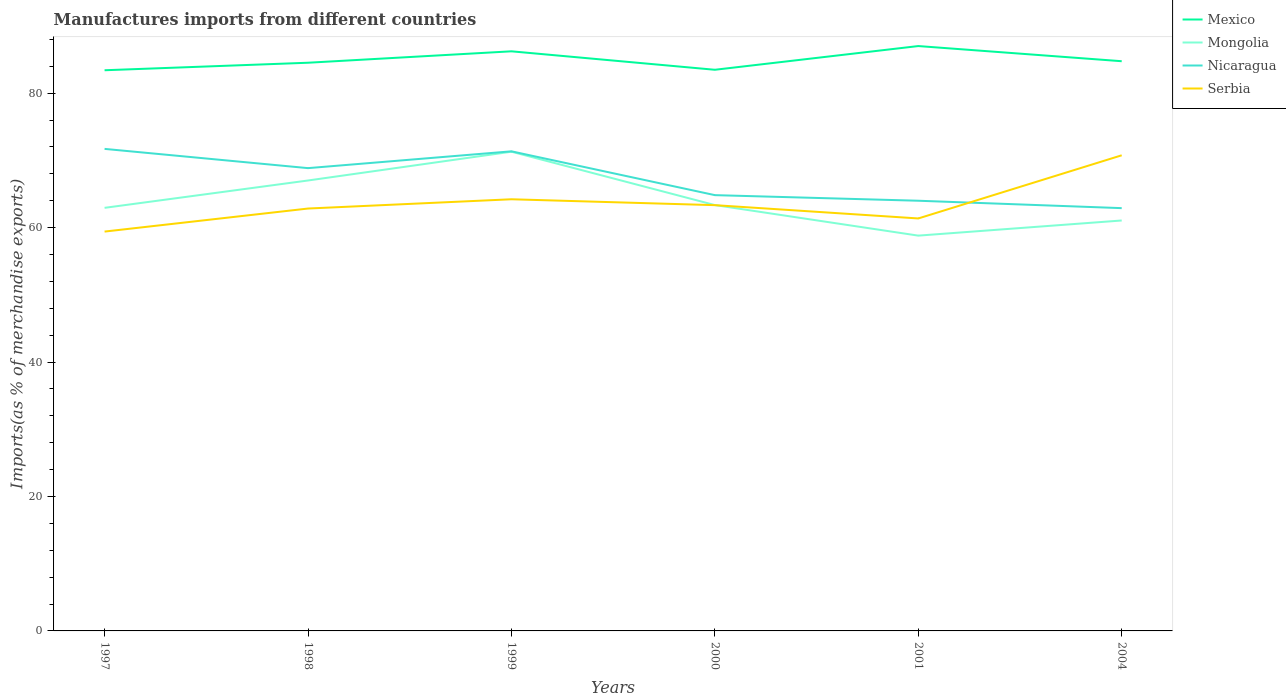Is the number of lines equal to the number of legend labels?
Your response must be concise. Yes. Across all years, what is the maximum percentage of imports to different countries in Serbia?
Give a very brief answer. 59.41. What is the total percentage of imports to different countries in Serbia in the graph?
Provide a short and direct response. -4.81. What is the difference between the highest and the second highest percentage of imports to different countries in Nicaragua?
Provide a succinct answer. 8.82. What is the difference between the highest and the lowest percentage of imports to different countries in Mongolia?
Your response must be concise. 2. Is the percentage of imports to different countries in Serbia strictly greater than the percentage of imports to different countries in Mexico over the years?
Ensure brevity in your answer.  Yes. What is the difference between two consecutive major ticks on the Y-axis?
Your answer should be very brief. 20. Does the graph contain any zero values?
Your response must be concise. No. How many legend labels are there?
Offer a very short reply. 4. How are the legend labels stacked?
Provide a short and direct response. Vertical. What is the title of the graph?
Your answer should be compact. Manufactures imports from different countries. Does "Netherlands" appear as one of the legend labels in the graph?
Ensure brevity in your answer.  No. What is the label or title of the Y-axis?
Ensure brevity in your answer.  Imports(as % of merchandise exports). What is the Imports(as % of merchandise exports) of Mexico in 1997?
Your response must be concise. 83.41. What is the Imports(as % of merchandise exports) of Mongolia in 1997?
Your response must be concise. 62.94. What is the Imports(as % of merchandise exports) in Nicaragua in 1997?
Your response must be concise. 71.71. What is the Imports(as % of merchandise exports) in Serbia in 1997?
Offer a terse response. 59.41. What is the Imports(as % of merchandise exports) of Mexico in 1998?
Your answer should be compact. 84.52. What is the Imports(as % of merchandise exports) of Mongolia in 1998?
Provide a short and direct response. 67.01. What is the Imports(as % of merchandise exports) of Nicaragua in 1998?
Make the answer very short. 68.84. What is the Imports(as % of merchandise exports) of Serbia in 1998?
Give a very brief answer. 62.83. What is the Imports(as % of merchandise exports) of Mexico in 1999?
Keep it short and to the point. 86.22. What is the Imports(as % of merchandise exports) of Mongolia in 1999?
Keep it short and to the point. 71.29. What is the Imports(as % of merchandise exports) in Nicaragua in 1999?
Provide a short and direct response. 71.34. What is the Imports(as % of merchandise exports) of Serbia in 1999?
Your answer should be very brief. 64.21. What is the Imports(as % of merchandise exports) in Mexico in 2000?
Your response must be concise. 83.48. What is the Imports(as % of merchandise exports) of Mongolia in 2000?
Provide a short and direct response. 63.35. What is the Imports(as % of merchandise exports) in Nicaragua in 2000?
Provide a short and direct response. 64.83. What is the Imports(as % of merchandise exports) of Serbia in 2000?
Make the answer very short. 63.34. What is the Imports(as % of merchandise exports) of Mexico in 2001?
Make the answer very short. 87. What is the Imports(as % of merchandise exports) of Mongolia in 2001?
Keep it short and to the point. 58.8. What is the Imports(as % of merchandise exports) in Nicaragua in 2001?
Make the answer very short. 63.99. What is the Imports(as % of merchandise exports) of Serbia in 2001?
Provide a short and direct response. 61.36. What is the Imports(as % of merchandise exports) of Mexico in 2004?
Give a very brief answer. 84.75. What is the Imports(as % of merchandise exports) of Mongolia in 2004?
Your response must be concise. 61.06. What is the Imports(as % of merchandise exports) of Nicaragua in 2004?
Provide a succinct answer. 62.89. What is the Imports(as % of merchandise exports) in Serbia in 2004?
Provide a short and direct response. 70.75. Across all years, what is the maximum Imports(as % of merchandise exports) of Mexico?
Provide a succinct answer. 87. Across all years, what is the maximum Imports(as % of merchandise exports) of Mongolia?
Your answer should be very brief. 71.29. Across all years, what is the maximum Imports(as % of merchandise exports) of Nicaragua?
Your answer should be compact. 71.71. Across all years, what is the maximum Imports(as % of merchandise exports) of Serbia?
Your response must be concise. 70.75. Across all years, what is the minimum Imports(as % of merchandise exports) in Mexico?
Give a very brief answer. 83.41. Across all years, what is the minimum Imports(as % of merchandise exports) in Mongolia?
Ensure brevity in your answer.  58.8. Across all years, what is the minimum Imports(as % of merchandise exports) of Nicaragua?
Ensure brevity in your answer.  62.89. Across all years, what is the minimum Imports(as % of merchandise exports) in Serbia?
Your answer should be very brief. 59.41. What is the total Imports(as % of merchandise exports) in Mexico in the graph?
Offer a very short reply. 509.38. What is the total Imports(as % of merchandise exports) in Mongolia in the graph?
Offer a terse response. 384.44. What is the total Imports(as % of merchandise exports) in Nicaragua in the graph?
Provide a succinct answer. 403.61. What is the total Imports(as % of merchandise exports) in Serbia in the graph?
Your response must be concise. 381.9. What is the difference between the Imports(as % of merchandise exports) of Mexico in 1997 and that in 1998?
Your answer should be compact. -1.12. What is the difference between the Imports(as % of merchandise exports) in Mongolia in 1997 and that in 1998?
Offer a terse response. -4.07. What is the difference between the Imports(as % of merchandise exports) of Nicaragua in 1997 and that in 1998?
Provide a short and direct response. 2.86. What is the difference between the Imports(as % of merchandise exports) in Serbia in 1997 and that in 1998?
Offer a very short reply. -3.43. What is the difference between the Imports(as % of merchandise exports) in Mexico in 1997 and that in 1999?
Offer a terse response. -2.82. What is the difference between the Imports(as % of merchandise exports) in Mongolia in 1997 and that in 1999?
Give a very brief answer. -8.35. What is the difference between the Imports(as % of merchandise exports) in Nicaragua in 1997 and that in 1999?
Make the answer very short. 0.36. What is the difference between the Imports(as % of merchandise exports) of Serbia in 1997 and that in 1999?
Provide a succinct answer. -4.81. What is the difference between the Imports(as % of merchandise exports) in Mexico in 1997 and that in 2000?
Your response must be concise. -0.07. What is the difference between the Imports(as % of merchandise exports) of Mongolia in 1997 and that in 2000?
Ensure brevity in your answer.  -0.41. What is the difference between the Imports(as % of merchandise exports) of Nicaragua in 1997 and that in 2000?
Provide a succinct answer. 6.88. What is the difference between the Imports(as % of merchandise exports) in Serbia in 1997 and that in 2000?
Offer a very short reply. -3.93. What is the difference between the Imports(as % of merchandise exports) of Mexico in 1997 and that in 2001?
Give a very brief answer. -3.6. What is the difference between the Imports(as % of merchandise exports) in Mongolia in 1997 and that in 2001?
Give a very brief answer. 4.13. What is the difference between the Imports(as % of merchandise exports) of Nicaragua in 1997 and that in 2001?
Give a very brief answer. 7.71. What is the difference between the Imports(as % of merchandise exports) in Serbia in 1997 and that in 2001?
Make the answer very short. -1.95. What is the difference between the Imports(as % of merchandise exports) in Mexico in 1997 and that in 2004?
Offer a very short reply. -1.34. What is the difference between the Imports(as % of merchandise exports) of Mongolia in 1997 and that in 2004?
Your answer should be very brief. 1.88. What is the difference between the Imports(as % of merchandise exports) of Nicaragua in 1997 and that in 2004?
Your answer should be compact. 8.82. What is the difference between the Imports(as % of merchandise exports) of Serbia in 1997 and that in 2004?
Your answer should be very brief. -11.35. What is the difference between the Imports(as % of merchandise exports) of Mexico in 1998 and that in 1999?
Keep it short and to the point. -1.7. What is the difference between the Imports(as % of merchandise exports) in Mongolia in 1998 and that in 1999?
Your answer should be very brief. -4.28. What is the difference between the Imports(as % of merchandise exports) of Nicaragua in 1998 and that in 1999?
Ensure brevity in your answer.  -2.5. What is the difference between the Imports(as % of merchandise exports) of Serbia in 1998 and that in 1999?
Provide a succinct answer. -1.38. What is the difference between the Imports(as % of merchandise exports) in Mexico in 1998 and that in 2000?
Ensure brevity in your answer.  1.05. What is the difference between the Imports(as % of merchandise exports) in Mongolia in 1998 and that in 2000?
Your response must be concise. 3.66. What is the difference between the Imports(as % of merchandise exports) of Nicaragua in 1998 and that in 2000?
Provide a succinct answer. 4.02. What is the difference between the Imports(as % of merchandise exports) of Serbia in 1998 and that in 2000?
Your answer should be compact. -0.5. What is the difference between the Imports(as % of merchandise exports) of Mexico in 1998 and that in 2001?
Give a very brief answer. -2.48. What is the difference between the Imports(as % of merchandise exports) of Mongolia in 1998 and that in 2001?
Provide a succinct answer. 8.2. What is the difference between the Imports(as % of merchandise exports) in Nicaragua in 1998 and that in 2001?
Make the answer very short. 4.85. What is the difference between the Imports(as % of merchandise exports) in Serbia in 1998 and that in 2001?
Your answer should be very brief. 1.48. What is the difference between the Imports(as % of merchandise exports) of Mexico in 1998 and that in 2004?
Provide a succinct answer. -0.23. What is the difference between the Imports(as % of merchandise exports) in Mongolia in 1998 and that in 2004?
Give a very brief answer. 5.95. What is the difference between the Imports(as % of merchandise exports) of Nicaragua in 1998 and that in 2004?
Give a very brief answer. 5.95. What is the difference between the Imports(as % of merchandise exports) in Serbia in 1998 and that in 2004?
Provide a short and direct response. -7.92. What is the difference between the Imports(as % of merchandise exports) in Mexico in 1999 and that in 2000?
Your response must be concise. 2.75. What is the difference between the Imports(as % of merchandise exports) in Mongolia in 1999 and that in 2000?
Your response must be concise. 7.94. What is the difference between the Imports(as % of merchandise exports) in Nicaragua in 1999 and that in 2000?
Ensure brevity in your answer.  6.52. What is the difference between the Imports(as % of merchandise exports) of Serbia in 1999 and that in 2000?
Offer a very short reply. 0.88. What is the difference between the Imports(as % of merchandise exports) in Mexico in 1999 and that in 2001?
Give a very brief answer. -0.78. What is the difference between the Imports(as % of merchandise exports) in Mongolia in 1999 and that in 2001?
Your answer should be very brief. 12.48. What is the difference between the Imports(as % of merchandise exports) in Nicaragua in 1999 and that in 2001?
Your answer should be compact. 7.35. What is the difference between the Imports(as % of merchandise exports) in Serbia in 1999 and that in 2001?
Make the answer very short. 2.85. What is the difference between the Imports(as % of merchandise exports) in Mexico in 1999 and that in 2004?
Your response must be concise. 1.47. What is the difference between the Imports(as % of merchandise exports) in Mongolia in 1999 and that in 2004?
Your answer should be compact. 10.23. What is the difference between the Imports(as % of merchandise exports) of Nicaragua in 1999 and that in 2004?
Your response must be concise. 8.45. What is the difference between the Imports(as % of merchandise exports) in Serbia in 1999 and that in 2004?
Your answer should be compact. -6.54. What is the difference between the Imports(as % of merchandise exports) in Mexico in 2000 and that in 2001?
Your answer should be compact. -3.53. What is the difference between the Imports(as % of merchandise exports) in Mongolia in 2000 and that in 2001?
Your response must be concise. 4.55. What is the difference between the Imports(as % of merchandise exports) in Nicaragua in 2000 and that in 2001?
Ensure brevity in your answer.  0.83. What is the difference between the Imports(as % of merchandise exports) of Serbia in 2000 and that in 2001?
Your response must be concise. 1.98. What is the difference between the Imports(as % of merchandise exports) in Mexico in 2000 and that in 2004?
Your response must be concise. -1.27. What is the difference between the Imports(as % of merchandise exports) in Mongolia in 2000 and that in 2004?
Make the answer very short. 2.29. What is the difference between the Imports(as % of merchandise exports) of Nicaragua in 2000 and that in 2004?
Your response must be concise. 1.94. What is the difference between the Imports(as % of merchandise exports) in Serbia in 2000 and that in 2004?
Offer a very short reply. -7.42. What is the difference between the Imports(as % of merchandise exports) of Mexico in 2001 and that in 2004?
Make the answer very short. 2.26. What is the difference between the Imports(as % of merchandise exports) of Mongolia in 2001 and that in 2004?
Provide a succinct answer. -2.25. What is the difference between the Imports(as % of merchandise exports) in Nicaragua in 2001 and that in 2004?
Your answer should be very brief. 1.1. What is the difference between the Imports(as % of merchandise exports) of Serbia in 2001 and that in 2004?
Offer a very short reply. -9.4. What is the difference between the Imports(as % of merchandise exports) of Mexico in 1997 and the Imports(as % of merchandise exports) of Mongolia in 1998?
Provide a short and direct response. 16.4. What is the difference between the Imports(as % of merchandise exports) in Mexico in 1997 and the Imports(as % of merchandise exports) in Nicaragua in 1998?
Your response must be concise. 14.56. What is the difference between the Imports(as % of merchandise exports) of Mexico in 1997 and the Imports(as % of merchandise exports) of Serbia in 1998?
Give a very brief answer. 20.57. What is the difference between the Imports(as % of merchandise exports) of Mongolia in 1997 and the Imports(as % of merchandise exports) of Nicaragua in 1998?
Make the answer very short. -5.91. What is the difference between the Imports(as % of merchandise exports) in Mongolia in 1997 and the Imports(as % of merchandise exports) in Serbia in 1998?
Make the answer very short. 0.1. What is the difference between the Imports(as % of merchandise exports) of Nicaragua in 1997 and the Imports(as % of merchandise exports) of Serbia in 1998?
Your answer should be very brief. 8.87. What is the difference between the Imports(as % of merchandise exports) of Mexico in 1997 and the Imports(as % of merchandise exports) of Mongolia in 1999?
Provide a succinct answer. 12.12. What is the difference between the Imports(as % of merchandise exports) of Mexico in 1997 and the Imports(as % of merchandise exports) of Nicaragua in 1999?
Your answer should be very brief. 12.06. What is the difference between the Imports(as % of merchandise exports) in Mexico in 1997 and the Imports(as % of merchandise exports) in Serbia in 1999?
Provide a succinct answer. 19.19. What is the difference between the Imports(as % of merchandise exports) of Mongolia in 1997 and the Imports(as % of merchandise exports) of Nicaragua in 1999?
Ensure brevity in your answer.  -8.41. What is the difference between the Imports(as % of merchandise exports) of Mongolia in 1997 and the Imports(as % of merchandise exports) of Serbia in 1999?
Ensure brevity in your answer.  -1.27. What is the difference between the Imports(as % of merchandise exports) in Nicaragua in 1997 and the Imports(as % of merchandise exports) in Serbia in 1999?
Keep it short and to the point. 7.49. What is the difference between the Imports(as % of merchandise exports) of Mexico in 1997 and the Imports(as % of merchandise exports) of Mongolia in 2000?
Offer a terse response. 20.06. What is the difference between the Imports(as % of merchandise exports) of Mexico in 1997 and the Imports(as % of merchandise exports) of Nicaragua in 2000?
Offer a terse response. 18.58. What is the difference between the Imports(as % of merchandise exports) in Mexico in 1997 and the Imports(as % of merchandise exports) in Serbia in 2000?
Your answer should be compact. 20.07. What is the difference between the Imports(as % of merchandise exports) in Mongolia in 1997 and the Imports(as % of merchandise exports) in Nicaragua in 2000?
Your answer should be very brief. -1.89. What is the difference between the Imports(as % of merchandise exports) in Mongolia in 1997 and the Imports(as % of merchandise exports) in Serbia in 2000?
Keep it short and to the point. -0.4. What is the difference between the Imports(as % of merchandise exports) in Nicaragua in 1997 and the Imports(as % of merchandise exports) in Serbia in 2000?
Make the answer very short. 8.37. What is the difference between the Imports(as % of merchandise exports) of Mexico in 1997 and the Imports(as % of merchandise exports) of Mongolia in 2001?
Your response must be concise. 24.6. What is the difference between the Imports(as % of merchandise exports) of Mexico in 1997 and the Imports(as % of merchandise exports) of Nicaragua in 2001?
Provide a succinct answer. 19.41. What is the difference between the Imports(as % of merchandise exports) in Mexico in 1997 and the Imports(as % of merchandise exports) in Serbia in 2001?
Your answer should be very brief. 22.05. What is the difference between the Imports(as % of merchandise exports) of Mongolia in 1997 and the Imports(as % of merchandise exports) of Nicaragua in 2001?
Provide a succinct answer. -1.06. What is the difference between the Imports(as % of merchandise exports) in Mongolia in 1997 and the Imports(as % of merchandise exports) in Serbia in 2001?
Make the answer very short. 1.58. What is the difference between the Imports(as % of merchandise exports) of Nicaragua in 1997 and the Imports(as % of merchandise exports) of Serbia in 2001?
Keep it short and to the point. 10.35. What is the difference between the Imports(as % of merchandise exports) in Mexico in 1997 and the Imports(as % of merchandise exports) in Mongolia in 2004?
Make the answer very short. 22.35. What is the difference between the Imports(as % of merchandise exports) in Mexico in 1997 and the Imports(as % of merchandise exports) in Nicaragua in 2004?
Your answer should be compact. 20.51. What is the difference between the Imports(as % of merchandise exports) in Mexico in 1997 and the Imports(as % of merchandise exports) in Serbia in 2004?
Provide a short and direct response. 12.65. What is the difference between the Imports(as % of merchandise exports) in Mongolia in 1997 and the Imports(as % of merchandise exports) in Nicaragua in 2004?
Your response must be concise. 0.05. What is the difference between the Imports(as % of merchandise exports) of Mongolia in 1997 and the Imports(as % of merchandise exports) of Serbia in 2004?
Offer a terse response. -7.82. What is the difference between the Imports(as % of merchandise exports) in Nicaragua in 1997 and the Imports(as % of merchandise exports) in Serbia in 2004?
Offer a very short reply. 0.95. What is the difference between the Imports(as % of merchandise exports) in Mexico in 1998 and the Imports(as % of merchandise exports) in Mongolia in 1999?
Keep it short and to the point. 13.24. What is the difference between the Imports(as % of merchandise exports) of Mexico in 1998 and the Imports(as % of merchandise exports) of Nicaragua in 1999?
Provide a succinct answer. 13.18. What is the difference between the Imports(as % of merchandise exports) of Mexico in 1998 and the Imports(as % of merchandise exports) of Serbia in 1999?
Ensure brevity in your answer.  20.31. What is the difference between the Imports(as % of merchandise exports) of Mongolia in 1998 and the Imports(as % of merchandise exports) of Nicaragua in 1999?
Provide a short and direct response. -4.34. What is the difference between the Imports(as % of merchandise exports) of Mongolia in 1998 and the Imports(as % of merchandise exports) of Serbia in 1999?
Provide a short and direct response. 2.79. What is the difference between the Imports(as % of merchandise exports) in Nicaragua in 1998 and the Imports(as % of merchandise exports) in Serbia in 1999?
Provide a short and direct response. 4.63. What is the difference between the Imports(as % of merchandise exports) in Mexico in 1998 and the Imports(as % of merchandise exports) in Mongolia in 2000?
Your answer should be very brief. 21.17. What is the difference between the Imports(as % of merchandise exports) in Mexico in 1998 and the Imports(as % of merchandise exports) in Nicaragua in 2000?
Ensure brevity in your answer.  19.7. What is the difference between the Imports(as % of merchandise exports) of Mexico in 1998 and the Imports(as % of merchandise exports) of Serbia in 2000?
Offer a terse response. 21.19. What is the difference between the Imports(as % of merchandise exports) in Mongolia in 1998 and the Imports(as % of merchandise exports) in Nicaragua in 2000?
Make the answer very short. 2.18. What is the difference between the Imports(as % of merchandise exports) in Mongolia in 1998 and the Imports(as % of merchandise exports) in Serbia in 2000?
Ensure brevity in your answer.  3.67. What is the difference between the Imports(as % of merchandise exports) in Nicaragua in 1998 and the Imports(as % of merchandise exports) in Serbia in 2000?
Give a very brief answer. 5.51. What is the difference between the Imports(as % of merchandise exports) in Mexico in 1998 and the Imports(as % of merchandise exports) in Mongolia in 2001?
Your answer should be compact. 25.72. What is the difference between the Imports(as % of merchandise exports) in Mexico in 1998 and the Imports(as % of merchandise exports) in Nicaragua in 2001?
Provide a succinct answer. 20.53. What is the difference between the Imports(as % of merchandise exports) of Mexico in 1998 and the Imports(as % of merchandise exports) of Serbia in 2001?
Provide a short and direct response. 23.17. What is the difference between the Imports(as % of merchandise exports) of Mongolia in 1998 and the Imports(as % of merchandise exports) of Nicaragua in 2001?
Your response must be concise. 3.01. What is the difference between the Imports(as % of merchandise exports) of Mongolia in 1998 and the Imports(as % of merchandise exports) of Serbia in 2001?
Your answer should be very brief. 5.65. What is the difference between the Imports(as % of merchandise exports) of Nicaragua in 1998 and the Imports(as % of merchandise exports) of Serbia in 2001?
Offer a very short reply. 7.49. What is the difference between the Imports(as % of merchandise exports) in Mexico in 1998 and the Imports(as % of merchandise exports) in Mongolia in 2004?
Provide a succinct answer. 23.47. What is the difference between the Imports(as % of merchandise exports) of Mexico in 1998 and the Imports(as % of merchandise exports) of Nicaragua in 2004?
Ensure brevity in your answer.  21.63. What is the difference between the Imports(as % of merchandise exports) of Mexico in 1998 and the Imports(as % of merchandise exports) of Serbia in 2004?
Your response must be concise. 13.77. What is the difference between the Imports(as % of merchandise exports) in Mongolia in 1998 and the Imports(as % of merchandise exports) in Nicaragua in 2004?
Offer a terse response. 4.11. What is the difference between the Imports(as % of merchandise exports) in Mongolia in 1998 and the Imports(as % of merchandise exports) in Serbia in 2004?
Make the answer very short. -3.75. What is the difference between the Imports(as % of merchandise exports) of Nicaragua in 1998 and the Imports(as % of merchandise exports) of Serbia in 2004?
Ensure brevity in your answer.  -1.91. What is the difference between the Imports(as % of merchandise exports) of Mexico in 1999 and the Imports(as % of merchandise exports) of Mongolia in 2000?
Provide a short and direct response. 22.87. What is the difference between the Imports(as % of merchandise exports) in Mexico in 1999 and the Imports(as % of merchandise exports) in Nicaragua in 2000?
Your answer should be very brief. 21.39. What is the difference between the Imports(as % of merchandise exports) in Mexico in 1999 and the Imports(as % of merchandise exports) in Serbia in 2000?
Ensure brevity in your answer.  22.89. What is the difference between the Imports(as % of merchandise exports) of Mongolia in 1999 and the Imports(as % of merchandise exports) of Nicaragua in 2000?
Give a very brief answer. 6.46. What is the difference between the Imports(as % of merchandise exports) of Mongolia in 1999 and the Imports(as % of merchandise exports) of Serbia in 2000?
Offer a terse response. 7.95. What is the difference between the Imports(as % of merchandise exports) of Nicaragua in 1999 and the Imports(as % of merchandise exports) of Serbia in 2000?
Your answer should be compact. 8.01. What is the difference between the Imports(as % of merchandise exports) of Mexico in 1999 and the Imports(as % of merchandise exports) of Mongolia in 2001?
Give a very brief answer. 27.42. What is the difference between the Imports(as % of merchandise exports) in Mexico in 1999 and the Imports(as % of merchandise exports) in Nicaragua in 2001?
Your answer should be compact. 22.23. What is the difference between the Imports(as % of merchandise exports) in Mexico in 1999 and the Imports(as % of merchandise exports) in Serbia in 2001?
Provide a succinct answer. 24.86. What is the difference between the Imports(as % of merchandise exports) of Mongolia in 1999 and the Imports(as % of merchandise exports) of Nicaragua in 2001?
Your answer should be very brief. 7.29. What is the difference between the Imports(as % of merchandise exports) of Mongolia in 1999 and the Imports(as % of merchandise exports) of Serbia in 2001?
Your answer should be very brief. 9.93. What is the difference between the Imports(as % of merchandise exports) in Nicaragua in 1999 and the Imports(as % of merchandise exports) in Serbia in 2001?
Offer a terse response. 9.99. What is the difference between the Imports(as % of merchandise exports) in Mexico in 1999 and the Imports(as % of merchandise exports) in Mongolia in 2004?
Your response must be concise. 25.17. What is the difference between the Imports(as % of merchandise exports) in Mexico in 1999 and the Imports(as % of merchandise exports) in Nicaragua in 2004?
Offer a terse response. 23.33. What is the difference between the Imports(as % of merchandise exports) in Mexico in 1999 and the Imports(as % of merchandise exports) in Serbia in 2004?
Ensure brevity in your answer.  15.47. What is the difference between the Imports(as % of merchandise exports) of Mongolia in 1999 and the Imports(as % of merchandise exports) of Nicaragua in 2004?
Make the answer very short. 8.4. What is the difference between the Imports(as % of merchandise exports) of Mongolia in 1999 and the Imports(as % of merchandise exports) of Serbia in 2004?
Your answer should be very brief. 0.53. What is the difference between the Imports(as % of merchandise exports) of Nicaragua in 1999 and the Imports(as % of merchandise exports) of Serbia in 2004?
Your response must be concise. 0.59. What is the difference between the Imports(as % of merchandise exports) in Mexico in 2000 and the Imports(as % of merchandise exports) in Mongolia in 2001?
Make the answer very short. 24.67. What is the difference between the Imports(as % of merchandise exports) of Mexico in 2000 and the Imports(as % of merchandise exports) of Nicaragua in 2001?
Make the answer very short. 19.48. What is the difference between the Imports(as % of merchandise exports) of Mexico in 2000 and the Imports(as % of merchandise exports) of Serbia in 2001?
Your answer should be very brief. 22.12. What is the difference between the Imports(as % of merchandise exports) of Mongolia in 2000 and the Imports(as % of merchandise exports) of Nicaragua in 2001?
Ensure brevity in your answer.  -0.64. What is the difference between the Imports(as % of merchandise exports) in Mongolia in 2000 and the Imports(as % of merchandise exports) in Serbia in 2001?
Offer a terse response. 1.99. What is the difference between the Imports(as % of merchandise exports) of Nicaragua in 2000 and the Imports(as % of merchandise exports) of Serbia in 2001?
Offer a terse response. 3.47. What is the difference between the Imports(as % of merchandise exports) in Mexico in 2000 and the Imports(as % of merchandise exports) in Mongolia in 2004?
Offer a terse response. 22.42. What is the difference between the Imports(as % of merchandise exports) in Mexico in 2000 and the Imports(as % of merchandise exports) in Nicaragua in 2004?
Offer a very short reply. 20.58. What is the difference between the Imports(as % of merchandise exports) in Mexico in 2000 and the Imports(as % of merchandise exports) in Serbia in 2004?
Make the answer very short. 12.72. What is the difference between the Imports(as % of merchandise exports) in Mongolia in 2000 and the Imports(as % of merchandise exports) in Nicaragua in 2004?
Give a very brief answer. 0.46. What is the difference between the Imports(as % of merchandise exports) in Mongolia in 2000 and the Imports(as % of merchandise exports) in Serbia in 2004?
Make the answer very short. -7.4. What is the difference between the Imports(as % of merchandise exports) of Nicaragua in 2000 and the Imports(as % of merchandise exports) of Serbia in 2004?
Offer a very short reply. -5.93. What is the difference between the Imports(as % of merchandise exports) of Mexico in 2001 and the Imports(as % of merchandise exports) of Mongolia in 2004?
Offer a very short reply. 25.95. What is the difference between the Imports(as % of merchandise exports) of Mexico in 2001 and the Imports(as % of merchandise exports) of Nicaragua in 2004?
Keep it short and to the point. 24.11. What is the difference between the Imports(as % of merchandise exports) in Mexico in 2001 and the Imports(as % of merchandise exports) in Serbia in 2004?
Make the answer very short. 16.25. What is the difference between the Imports(as % of merchandise exports) in Mongolia in 2001 and the Imports(as % of merchandise exports) in Nicaragua in 2004?
Make the answer very short. -4.09. What is the difference between the Imports(as % of merchandise exports) in Mongolia in 2001 and the Imports(as % of merchandise exports) in Serbia in 2004?
Provide a short and direct response. -11.95. What is the difference between the Imports(as % of merchandise exports) in Nicaragua in 2001 and the Imports(as % of merchandise exports) in Serbia in 2004?
Give a very brief answer. -6.76. What is the average Imports(as % of merchandise exports) of Mexico per year?
Your response must be concise. 84.9. What is the average Imports(as % of merchandise exports) of Mongolia per year?
Make the answer very short. 64.07. What is the average Imports(as % of merchandise exports) of Nicaragua per year?
Your answer should be compact. 67.27. What is the average Imports(as % of merchandise exports) of Serbia per year?
Provide a succinct answer. 63.65. In the year 1997, what is the difference between the Imports(as % of merchandise exports) of Mexico and Imports(as % of merchandise exports) of Mongolia?
Your response must be concise. 20.47. In the year 1997, what is the difference between the Imports(as % of merchandise exports) in Mexico and Imports(as % of merchandise exports) in Nicaragua?
Provide a succinct answer. 11.7. In the year 1997, what is the difference between the Imports(as % of merchandise exports) in Mexico and Imports(as % of merchandise exports) in Serbia?
Provide a short and direct response. 24. In the year 1997, what is the difference between the Imports(as % of merchandise exports) in Mongolia and Imports(as % of merchandise exports) in Nicaragua?
Keep it short and to the point. -8.77. In the year 1997, what is the difference between the Imports(as % of merchandise exports) in Mongolia and Imports(as % of merchandise exports) in Serbia?
Provide a succinct answer. 3.53. In the year 1997, what is the difference between the Imports(as % of merchandise exports) of Nicaragua and Imports(as % of merchandise exports) of Serbia?
Provide a short and direct response. 12.3. In the year 1998, what is the difference between the Imports(as % of merchandise exports) of Mexico and Imports(as % of merchandise exports) of Mongolia?
Provide a short and direct response. 17.52. In the year 1998, what is the difference between the Imports(as % of merchandise exports) in Mexico and Imports(as % of merchandise exports) in Nicaragua?
Your answer should be compact. 15.68. In the year 1998, what is the difference between the Imports(as % of merchandise exports) in Mexico and Imports(as % of merchandise exports) in Serbia?
Provide a short and direct response. 21.69. In the year 1998, what is the difference between the Imports(as % of merchandise exports) in Mongolia and Imports(as % of merchandise exports) in Nicaragua?
Provide a short and direct response. -1.84. In the year 1998, what is the difference between the Imports(as % of merchandise exports) of Mongolia and Imports(as % of merchandise exports) of Serbia?
Offer a terse response. 4.17. In the year 1998, what is the difference between the Imports(as % of merchandise exports) of Nicaragua and Imports(as % of merchandise exports) of Serbia?
Ensure brevity in your answer.  6.01. In the year 1999, what is the difference between the Imports(as % of merchandise exports) in Mexico and Imports(as % of merchandise exports) in Mongolia?
Offer a very short reply. 14.93. In the year 1999, what is the difference between the Imports(as % of merchandise exports) of Mexico and Imports(as % of merchandise exports) of Nicaragua?
Give a very brief answer. 14.88. In the year 1999, what is the difference between the Imports(as % of merchandise exports) of Mexico and Imports(as % of merchandise exports) of Serbia?
Provide a short and direct response. 22.01. In the year 1999, what is the difference between the Imports(as % of merchandise exports) in Mongolia and Imports(as % of merchandise exports) in Nicaragua?
Keep it short and to the point. -0.06. In the year 1999, what is the difference between the Imports(as % of merchandise exports) of Mongolia and Imports(as % of merchandise exports) of Serbia?
Your answer should be very brief. 7.08. In the year 1999, what is the difference between the Imports(as % of merchandise exports) in Nicaragua and Imports(as % of merchandise exports) in Serbia?
Offer a very short reply. 7.13. In the year 2000, what is the difference between the Imports(as % of merchandise exports) of Mexico and Imports(as % of merchandise exports) of Mongolia?
Provide a short and direct response. 20.13. In the year 2000, what is the difference between the Imports(as % of merchandise exports) of Mexico and Imports(as % of merchandise exports) of Nicaragua?
Offer a very short reply. 18.65. In the year 2000, what is the difference between the Imports(as % of merchandise exports) of Mexico and Imports(as % of merchandise exports) of Serbia?
Provide a short and direct response. 20.14. In the year 2000, what is the difference between the Imports(as % of merchandise exports) of Mongolia and Imports(as % of merchandise exports) of Nicaragua?
Your answer should be compact. -1.48. In the year 2000, what is the difference between the Imports(as % of merchandise exports) of Mongolia and Imports(as % of merchandise exports) of Serbia?
Keep it short and to the point. 0.01. In the year 2000, what is the difference between the Imports(as % of merchandise exports) of Nicaragua and Imports(as % of merchandise exports) of Serbia?
Offer a terse response. 1.49. In the year 2001, what is the difference between the Imports(as % of merchandise exports) of Mexico and Imports(as % of merchandise exports) of Mongolia?
Keep it short and to the point. 28.2. In the year 2001, what is the difference between the Imports(as % of merchandise exports) in Mexico and Imports(as % of merchandise exports) in Nicaragua?
Provide a succinct answer. 23.01. In the year 2001, what is the difference between the Imports(as % of merchandise exports) of Mexico and Imports(as % of merchandise exports) of Serbia?
Provide a short and direct response. 25.65. In the year 2001, what is the difference between the Imports(as % of merchandise exports) in Mongolia and Imports(as % of merchandise exports) in Nicaragua?
Provide a short and direct response. -5.19. In the year 2001, what is the difference between the Imports(as % of merchandise exports) in Mongolia and Imports(as % of merchandise exports) in Serbia?
Make the answer very short. -2.55. In the year 2001, what is the difference between the Imports(as % of merchandise exports) in Nicaragua and Imports(as % of merchandise exports) in Serbia?
Keep it short and to the point. 2.64. In the year 2004, what is the difference between the Imports(as % of merchandise exports) in Mexico and Imports(as % of merchandise exports) in Mongolia?
Keep it short and to the point. 23.69. In the year 2004, what is the difference between the Imports(as % of merchandise exports) in Mexico and Imports(as % of merchandise exports) in Nicaragua?
Offer a very short reply. 21.86. In the year 2004, what is the difference between the Imports(as % of merchandise exports) of Mexico and Imports(as % of merchandise exports) of Serbia?
Your answer should be very brief. 14. In the year 2004, what is the difference between the Imports(as % of merchandise exports) in Mongolia and Imports(as % of merchandise exports) in Nicaragua?
Your answer should be compact. -1.84. In the year 2004, what is the difference between the Imports(as % of merchandise exports) of Mongolia and Imports(as % of merchandise exports) of Serbia?
Your answer should be very brief. -9.7. In the year 2004, what is the difference between the Imports(as % of merchandise exports) of Nicaragua and Imports(as % of merchandise exports) of Serbia?
Your answer should be compact. -7.86. What is the ratio of the Imports(as % of merchandise exports) in Mongolia in 1997 to that in 1998?
Make the answer very short. 0.94. What is the ratio of the Imports(as % of merchandise exports) in Nicaragua in 1997 to that in 1998?
Provide a succinct answer. 1.04. What is the ratio of the Imports(as % of merchandise exports) in Serbia in 1997 to that in 1998?
Your answer should be very brief. 0.95. What is the ratio of the Imports(as % of merchandise exports) in Mexico in 1997 to that in 1999?
Make the answer very short. 0.97. What is the ratio of the Imports(as % of merchandise exports) of Mongolia in 1997 to that in 1999?
Provide a short and direct response. 0.88. What is the ratio of the Imports(as % of merchandise exports) in Nicaragua in 1997 to that in 1999?
Make the answer very short. 1.01. What is the ratio of the Imports(as % of merchandise exports) of Serbia in 1997 to that in 1999?
Make the answer very short. 0.93. What is the ratio of the Imports(as % of merchandise exports) in Mongolia in 1997 to that in 2000?
Offer a terse response. 0.99. What is the ratio of the Imports(as % of merchandise exports) in Nicaragua in 1997 to that in 2000?
Your answer should be very brief. 1.11. What is the ratio of the Imports(as % of merchandise exports) in Serbia in 1997 to that in 2000?
Keep it short and to the point. 0.94. What is the ratio of the Imports(as % of merchandise exports) of Mexico in 1997 to that in 2001?
Offer a terse response. 0.96. What is the ratio of the Imports(as % of merchandise exports) of Mongolia in 1997 to that in 2001?
Give a very brief answer. 1.07. What is the ratio of the Imports(as % of merchandise exports) in Nicaragua in 1997 to that in 2001?
Provide a succinct answer. 1.12. What is the ratio of the Imports(as % of merchandise exports) of Serbia in 1997 to that in 2001?
Provide a succinct answer. 0.97. What is the ratio of the Imports(as % of merchandise exports) of Mexico in 1997 to that in 2004?
Your answer should be very brief. 0.98. What is the ratio of the Imports(as % of merchandise exports) in Mongolia in 1997 to that in 2004?
Keep it short and to the point. 1.03. What is the ratio of the Imports(as % of merchandise exports) in Nicaragua in 1997 to that in 2004?
Provide a short and direct response. 1.14. What is the ratio of the Imports(as % of merchandise exports) in Serbia in 1997 to that in 2004?
Provide a succinct answer. 0.84. What is the ratio of the Imports(as % of merchandise exports) of Mexico in 1998 to that in 1999?
Your answer should be compact. 0.98. What is the ratio of the Imports(as % of merchandise exports) of Mongolia in 1998 to that in 1999?
Your answer should be compact. 0.94. What is the ratio of the Imports(as % of merchandise exports) of Nicaragua in 1998 to that in 1999?
Give a very brief answer. 0.96. What is the ratio of the Imports(as % of merchandise exports) in Serbia in 1998 to that in 1999?
Your answer should be very brief. 0.98. What is the ratio of the Imports(as % of merchandise exports) of Mexico in 1998 to that in 2000?
Provide a succinct answer. 1.01. What is the ratio of the Imports(as % of merchandise exports) of Mongolia in 1998 to that in 2000?
Ensure brevity in your answer.  1.06. What is the ratio of the Imports(as % of merchandise exports) of Nicaragua in 1998 to that in 2000?
Provide a short and direct response. 1.06. What is the ratio of the Imports(as % of merchandise exports) of Mexico in 1998 to that in 2001?
Provide a succinct answer. 0.97. What is the ratio of the Imports(as % of merchandise exports) in Mongolia in 1998 to that in 2001?
Make the answer very short. 1.14. What is the ratio of the Imports(as % of merchandise exports) of Nicaragua in 1998 to that in 2001?
Offer a terse response. 1.08. What is the ratio of the Imports(as % of merchandise exports) in Serbia in 1998 to that in 2001?
Give a very brief answer. 1.02. What is the ratio of the Imports(as % of merchandise exports) of Mexico in 1998 to that in 2004?
Provide a succinct answer. 1. What is the ratio of the Imports(as % of merchandise exports) in Mongolia in 1998 to that in 2004?
Offer a very short reply. 1.1. What is the ratio of the Imports(as % of merchandise exports) of Nicaragua in 1998 to that in 2004?
Make the answer very short. 1.09. What is the ratio of the Imports(as % of merchandise exports) of Serbia in 1998 to that in 2004?
Keep it short and to the point. 0.89. What is the ratio of the Imports(as % of merchandise exports) of Mexico in 1999 to that in 2000?
Offer a terse response. 1.03. What is the ratio of the Imports(as % of merchandise exports) of Mongolia in 1999 to that in 2000?
Make the answer very short. 1.13. What is the ratio of the Imports(as % of merchandise exports) of Nicaragua in 1999 to that in 2000?
Offer a very short reply. 1.1. What is the ratio of the Imports(as % of merchandise exports) of Serbia in 1999 to that in 2000?
Offer a terse response. 1.01. What is the ratio of the Imports(as % of merchandise exports) in Mongolia in 1999 to that in 2001?
Offer a very short reply. 1.21. What is the ratio of the Imports(as % of merchandise exports) in Nicaragua in 1999 to that in 2001?
Provide a short and direct response. 1.11. What is the ratio of the Imports(as % of merchandise exports) in Serbia in 1999 to that in 2001?
Keep it short and to the point. 1.05. What is the ratio of the Imports(as % of merchandise exports) in Mexico in 1999 to that in 2004?
Give a very brief answer. 1.02. What is the ratio of the Imports(as % of merchandise exports) in Mongolia in 1999 to that in 2004?
Provide a short and direct response. 1.17. What is the ratio of the Imports(as % of merchandise exports) of Nicaragua in 1999 to that in 2004?
Your answer should be compact. 1.13. What is the ratio of the Imports(as % of merchandise exports) of Serbia in 1999 to that in 2004?
Your response must be concise. 0.91. What is the ratio of the Imports(as % of merchandise exports) in Mexico in 2000 to that in 2001?
Offer a terse response. 0.96. What is the ratio of the Imports(as % of merchandise exports) in Mongolia in 2000 to that in 2001?
Provide a succinct answer. 1.08. What is the ratio of the Imports(as % of merchandise exports) in Serbia in 2000 to that in 2001?
Provide a succinct answer. 1.03. What is the ratio of the Imports(as % of merchandise exports) of Mexico in 2000 to that in 2004?
Provide a succinct answer. 0.98. What is the ratio of the Imports(as % of merchandise exports) of Mongolia in 2000 to that in 2004?
Your answer should be compact. 1.04. What is the ratio of the Imports(as % of merchandise exports) of Nicaragua in 2000 to that in 2004?
Make the answer very short. 1.03. What is the ratio of the Imports(as % of merchandise exports) of Serbia in 2000 to that in 2004?
Your answer should be compact. 0.9. What is the ratio of the Imports(as % of merchandise exports) of Mexico in 2001 to that in 2004?
Your answer should be compact. 1.03. What is the ratio of the Imports(as % of merchandise exports) in Mongolia in 2001 to that in 2004?
Provide a short and direct response. 0.96. What is the ratio of the Imports(as % of merchandise exports) in Nicaragua in 2001 to that in 2004?
Provide a succinct answer. 1.02. What is the ratio of the Imports(as % of merchandise exports) in Serbia in 2001 to that in 2004?
Give a very brief answer. 0.87. What is the difference between the highest and the second highest Imports(as % of merchandise exports) in Mexico?
Offer a very short reply. 0.78. What is the difference between the highest and the second highest Imports(as % of merchandise exports) in Mongolia?
Your answer should be compact. 4.28. What is the difference between the highest and the second highest Imports(as % of merchandise exports) of Nicaragua?
Offer a terse response. 0.36. What is the difference between the highest and the second highest Imports(as % of merchandise exports) of Serbia?
Offer a very short reply. 6.54. What is the difference between the highest and the lowest Imports(as % of merchandise exports) in Mexico?
Your answer should be compact. 3.6. What is the difference between the highest and the lowest Imports(as % of merchandise exports) in Mongolia?
Offer a very short reply. 12.48. What is the difference between the highest and the lowest Imports(as % of merchandise exports) in Nicaragua?
Your answer should be very brief. 8.82. What is the difference between the highest and the lowest Imports(as % of merchandise exports) of Serbia?
Offer a terse response. 11.35. 